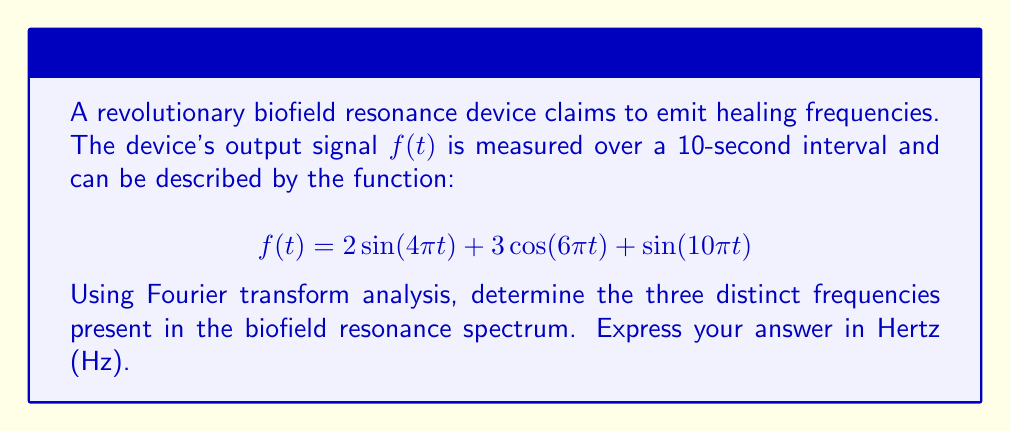What is the answer to this math problem? To find the frequency spectrum using Fourier transform analysis, we need to identify the angular frequencies in the given function and convert them to Hz. The general form of a sinusoidal function is $A\sin(\omega t)$ or $A\cos(\omega t)$, where $\omega$ is the angular frequency in radians per second.

Step 1: Identify the angular frequencies
- For $2\sin(4\pi t)$: $\omega_1 = 4\pi$ rad/s
- For $3\cos(6\pi t)$: $\omega_2 = 6\pi$ rad/s
- For $\sin(10\pi t)$: $\omega_3 = 10\pi$ rad/s

Step 2: Convert angular frequencies to Hz
The relationship between angular frequency $\omega$ (in rad/s) and frequency $f$ (in Hz) is:

$$f = \frac{\omega}{2\pi}$$

Applying this to each term:

$f_1 = \frac{4\pi}{2\pi} = 2$ Hz
$f_2 = \frac{6\pi}{2\pi} = 3$ Hz
$f_3 = \frac{10\pi}{2\pi} = 5$ Hz

Therefore, the three distinct frequencies in the biofield resonance spectrum are 2 Hz, 3 Hz, and 5 Hz.
Answer: 2 Hz, 3 Hz, 5 Hz 